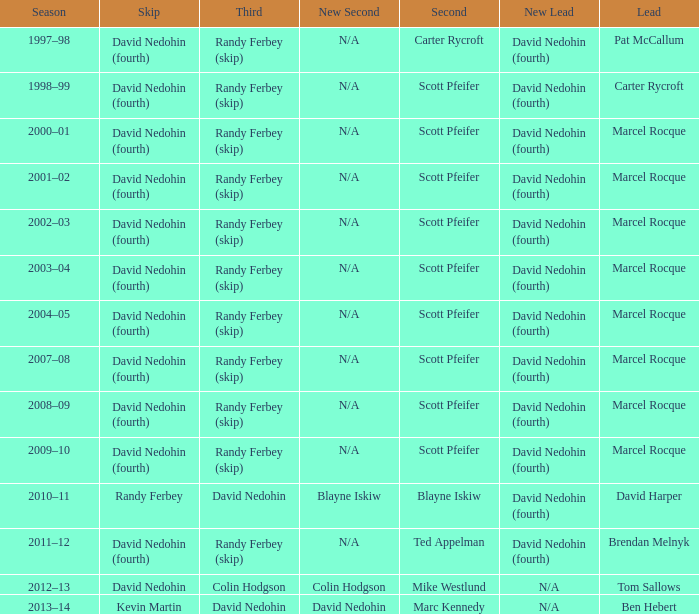Which Lead has a Third of randy ferbey (skip), a Second of scott pfeifer, and a Season of 2009–10? Marcel Rocque. 